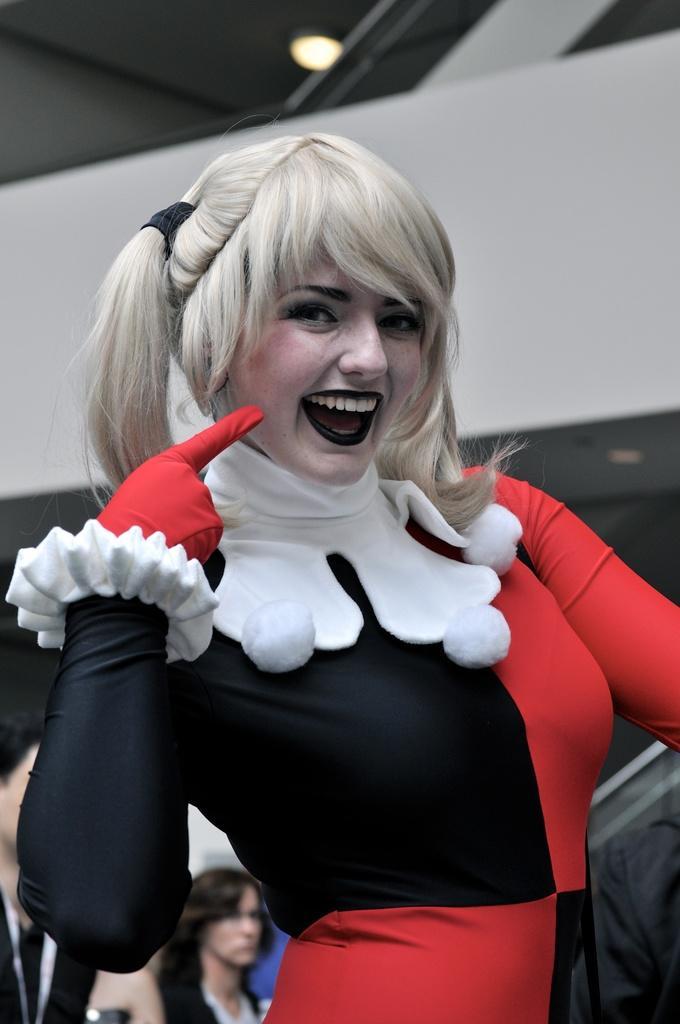Can you describe this image briefly? In this image there is a woman wearing a costume. Left bottom there are people. Background there is a wall. Top of the image there is a light attached to the roof. 